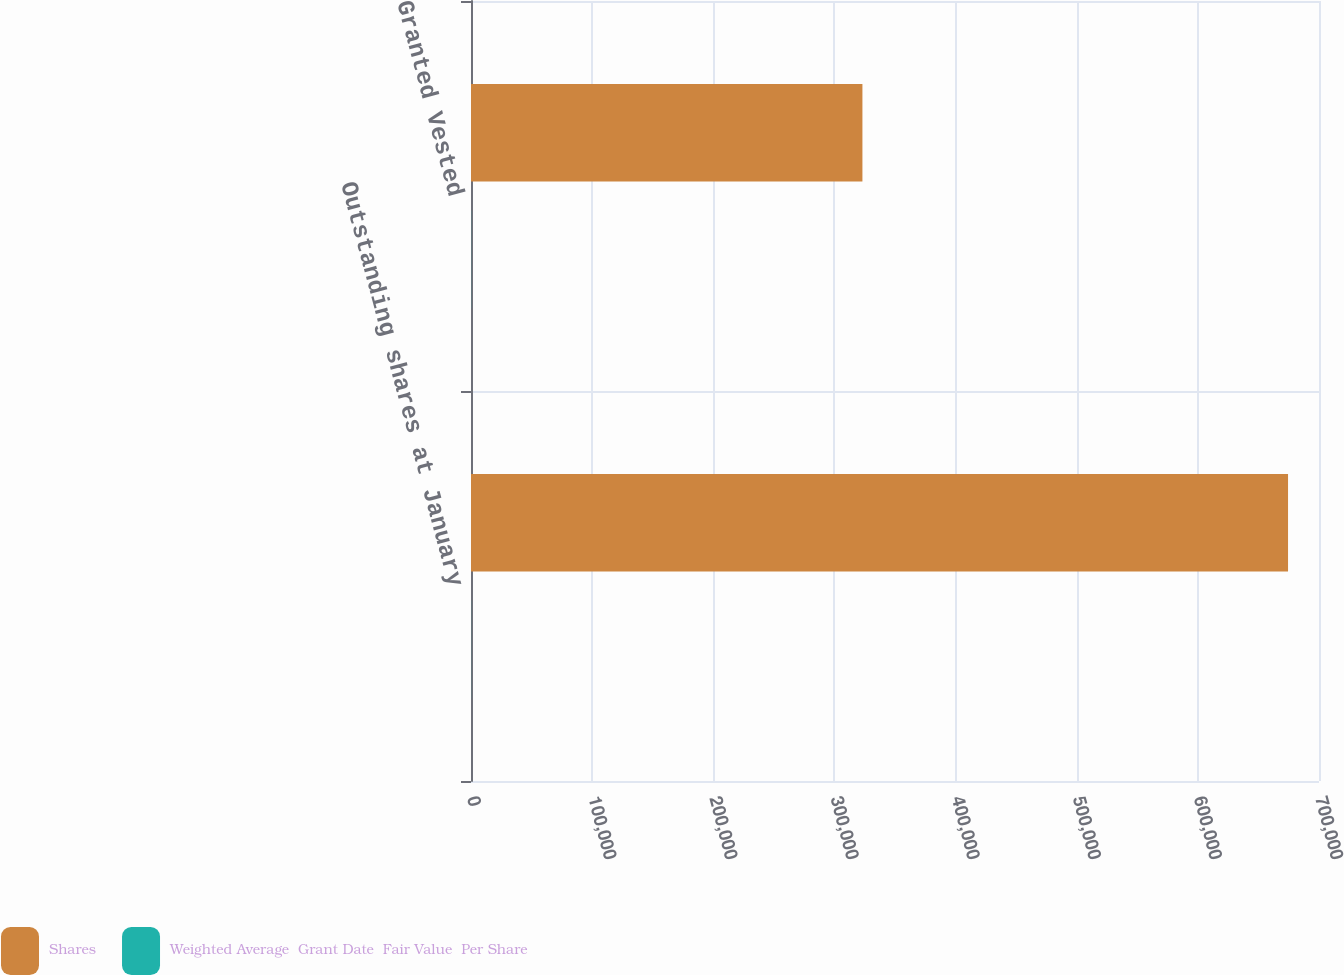Convert chart. <chart><loc_0><loc_0><loc_500><loc_500><stacked_bar_chart><ecel><fcel>Outstanding shares at January<fcel>Granted Vested<nl><fcel>Shares<fcel>674445<fcel>323110<nl><fcel>Weighted Average  Grant Date  Fair Value  Per Share<fcel>64.82<fcel>88.58<nl></chart> 